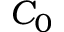<formula> <loc_0><loc_0><loc_500><loc_500>C _ { 0 }</formula> 